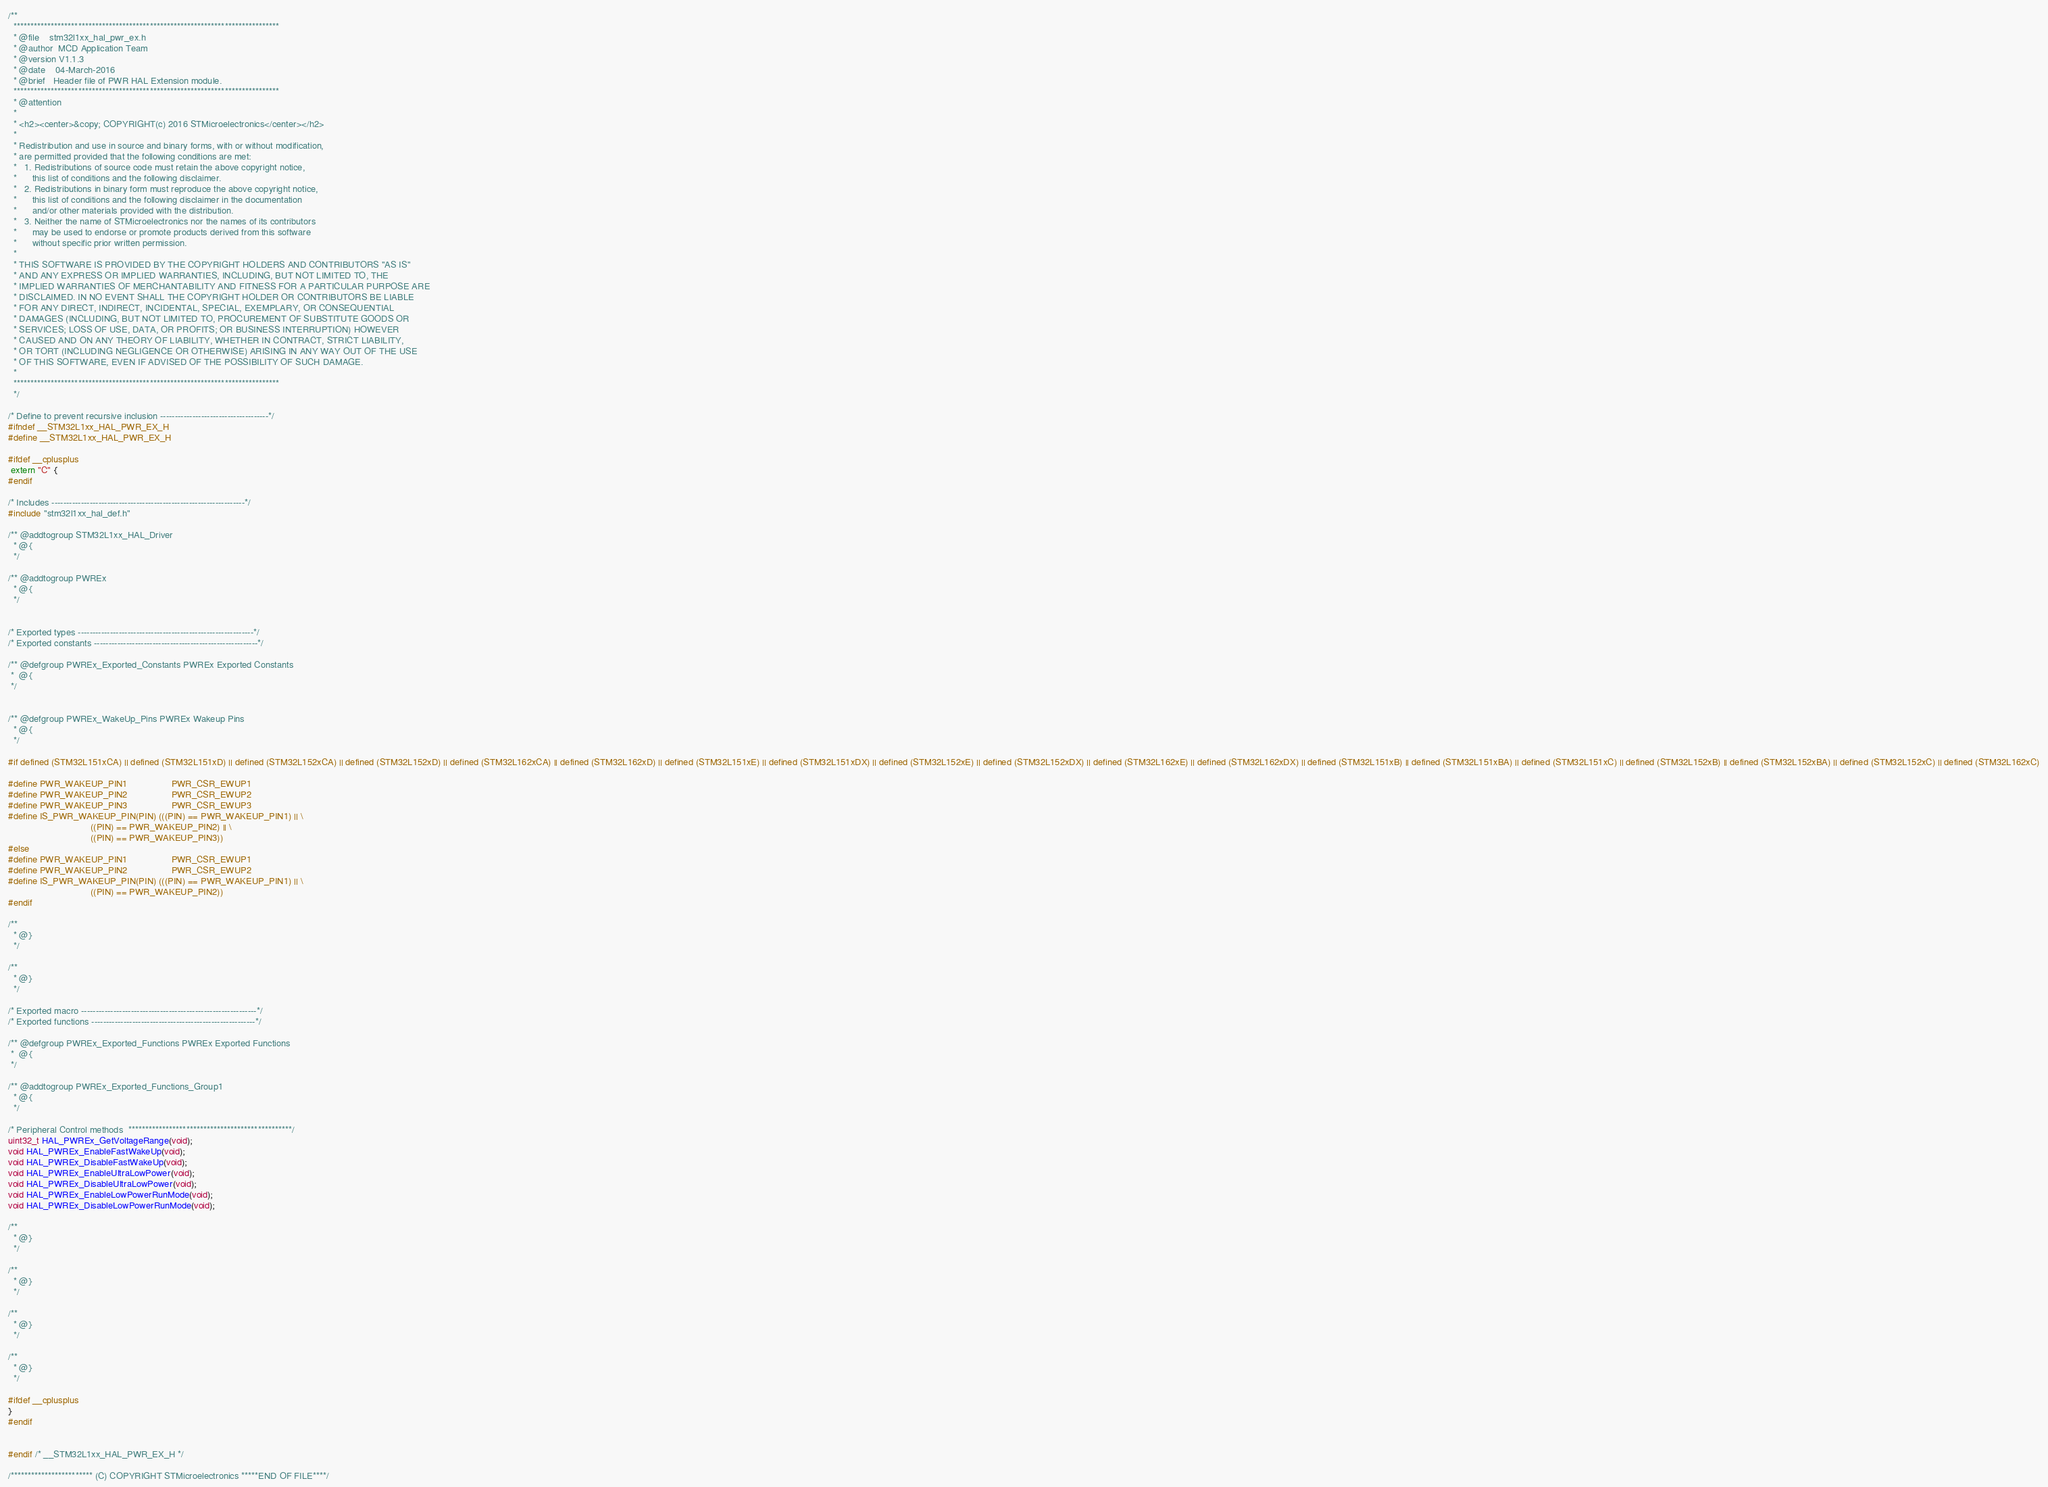Convert code to text. <code><loc_0><loc_0><loc_500><loc_500><_C_>/**
  ******************************************************************************
  * @file    stm32l1xx_hal_pwr_ex.h
  * @author  MCD Application Team
  * @version V1.1.3
  * @date    04-March-2016
  * @brief   Header file of PWR HAL Extension module.
  ******************************************************************************
  * @attention
  *
  * <h2><center>&copy; COPYRIGHT(c) 2016 STMicroelectronics</center></h2>
  *
  * Redistribution and use in source and binary forms, with or without modification,
  * are permitted provided that the following conditions are met:
  *   1. Redistributions of source code must retain the above copyright notice,
  *      this list of conditions and the following disclaimer.
  *   2. Redistributions in binary form must reproduce the above copyright notice,
  *      this list of conditions and the following disclaimer in the documentation
  *      and/or other materials provided with the distribution.
  *   3. Neither the name of STMicroelectronics nor the names of its contributors
  *      may be used to endorse or promote products derived from this software
  *      without specific prior written permission.
  *
  * THIS SOFTWARE IS PROVIDED BY THE COPYRIGHT HOLDERS AND CONTRIBUTORS "AS IS"
  * AND ANY EXPRESS OR IMPLIED WARRANTIES, INCLUDING, BUT NOT LIMITED TO, THE
  * IMPLIED WARRANTIES OF MERCHANTABILITY AND FITNESS FOR A PARTICULAR PURPOSE ARE
  * DISCLAIMED. IN NO EVENT SHALL THE COPYRIGHT HOLDER OR CONTRIBUTORS BE LIABLE
  * FOR ANY DIRECT, INDIRECT, INCIDENTAL, SPECIAL, EXEMPLARY, OR CONSEQUENTIAL
  * DAMAGES (INCLUDING, BUT NOT LIMITED TO, PROCUREMENT OF SUBSTITUTE GOODS OR
  * SERVICES; LOSS OF USE, DATA, OR PROFITS; OR BUSINESS INTERRUPTION) HOWEVER
  * CAUSED AND ON ANY THEORY OF LIABILITY, WHETHER IN CONTRACT, STRICT LIABILITY,
  * OR TORT (INCLUDING NEGLIGENCE OR OTHERWISE) ARISING IN ANY WAY OUT OF THE USE
  * OF THIS SOFTWARE, EVEN IF ADVISED OF THE POSSIBILITY OF SUCH DAMAGE.
  *
  ******************************************************************************
  */

/* Define to prevent recursive inclusion -------------------------------------*/
#ifndef __STM32L1xx_HAL_PWR_EX_H
#define __STM32L1xx_HAL_PWR_EX_H

#ifdef __cplusplus
 extern "C" {
#endif

/* Includes ------------------------------------------------------------------*/
#include "stm32l1xx_hal_def.h"

/** @addtogroup STM32L1xx_HAL_Driver
  * @{
  */

/** @addtogroup PWREx
  * @{
  */


/* Exported types ------------------------------------------------------------*/
/* Exported constants --------------------------------------------------------*/

/** @defgroup PWREx_Exported_Constants PWREx Exported Constants
 *  @{
 */


/** @defgroup PWREx_WakeUp_Pins PWREx Wakeup Pins
  * @{
  */

#if defined (STM32L151xCA) || defined (STM32L151xD) || defined (STM32L152xCA) || defined (STM32L152xD) || defined (STM32L162xCA) || defined (STM32L162xD) || defined (STM32L151xE) || defined (STM32L151xDX) || defined (STM32L152xE) || defined (STM32L152xDX) || defined (STM32L162xE) || defined (STM32L162xDX) || defined (STM32L151xB) || defined (STM32L151xBA) || defined (STM32L151xC) || defined (STM32L152xB) || defined (STM32L152xBA) || defined (STM32L152xC) || defined (STM32L162xC)

#define PWR_WAKEUP_PIN1                 PWR_CSR_EWUP1
#define PWR_WAKEUP_PIN2                 PWR_CSR_EWUP2
#define PWR_WAKEUP_PIN3                 PWR_CSR_EWUP3
#define IS_PWR_WAKEUP_PIN(PIN) (((PIN) == PWR_WAKEUP_PIN1) || \
                                ((PIN) == PWR_WAKEUP_PIN2) || \
                                ((PIN) == PWR_WAKEUP_PIN3))
#else
#define PWR_WAKEUP_PIN1                 PWR_CSR_EWUP1
#define PWR_WAKEUP_PIN2                 PWR_CSR_EWUP2
#define IS_PWR_WAKEUP_PIN(PIN) (((PIN) == PWR_WAKEUP_PIN1) || \
                                ((PIN) == PWR_WAKEUP_PIN2))
#endif

/**
  * @}
  */

/**
  * @}
  */
  
/* Exported macro ------------------------------------------------------------*/
/* Exported functions --------------------------------------------------------*/

/** @defgroup PWREx_Exported_Functions PWREx Exported Functions
 *  @{
 */
 
/** @addtogroup PWREx_Exported_Functions_Group1
  * @{
  */
  
/* Peripheral Control methods  ************************************************/
uint32_t HAL_PWREx_GetVoltageRange(void);
void HAL_PWREx_EnableFastWakeUp(void);
void HAL_PWREx_DisableFastWakeUp(void);
void HAL_PWREx_EnableUltraLowPower(void);
void HAL_PWREx_DisableUltraLowPower(void);
void HAL_PWREx_EnableLowPowerRunMode(void);
void HAL_PWREx_DisableLowPowerRunMode(void);

/**
  * @}
  */

/**
  * @}
  */

/**
  * @}
  */

/**
  * @}
  */

#ifdef __cplusplus
}
#endif


#endif /* __STM32L1xx_HAL_PWR_EX_H */

/************************ (C) COPYRIGHT STMicroelectronics *****END OF FILE****/
</code> 